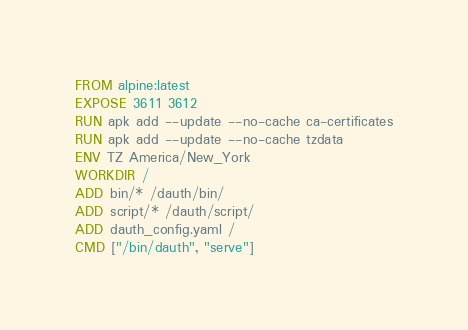Convert code to text. <code><loc_0><loc_0><loc_500><loc_500><_Dockerfile_>FROM alpine:latest
EXPOSE 3611 3612
RUN apk add --update --no-cache ca-certificates
RUN apk add --update --no-cache tzdata
ENV TZ America/New_York
WORKDIR /
ADD bin/* /dauth/bin/
ADD script/* /dauth/script/
ADD dauth_config.yaml /
CMD ["/bin/dauth", "serve"]
</code> 